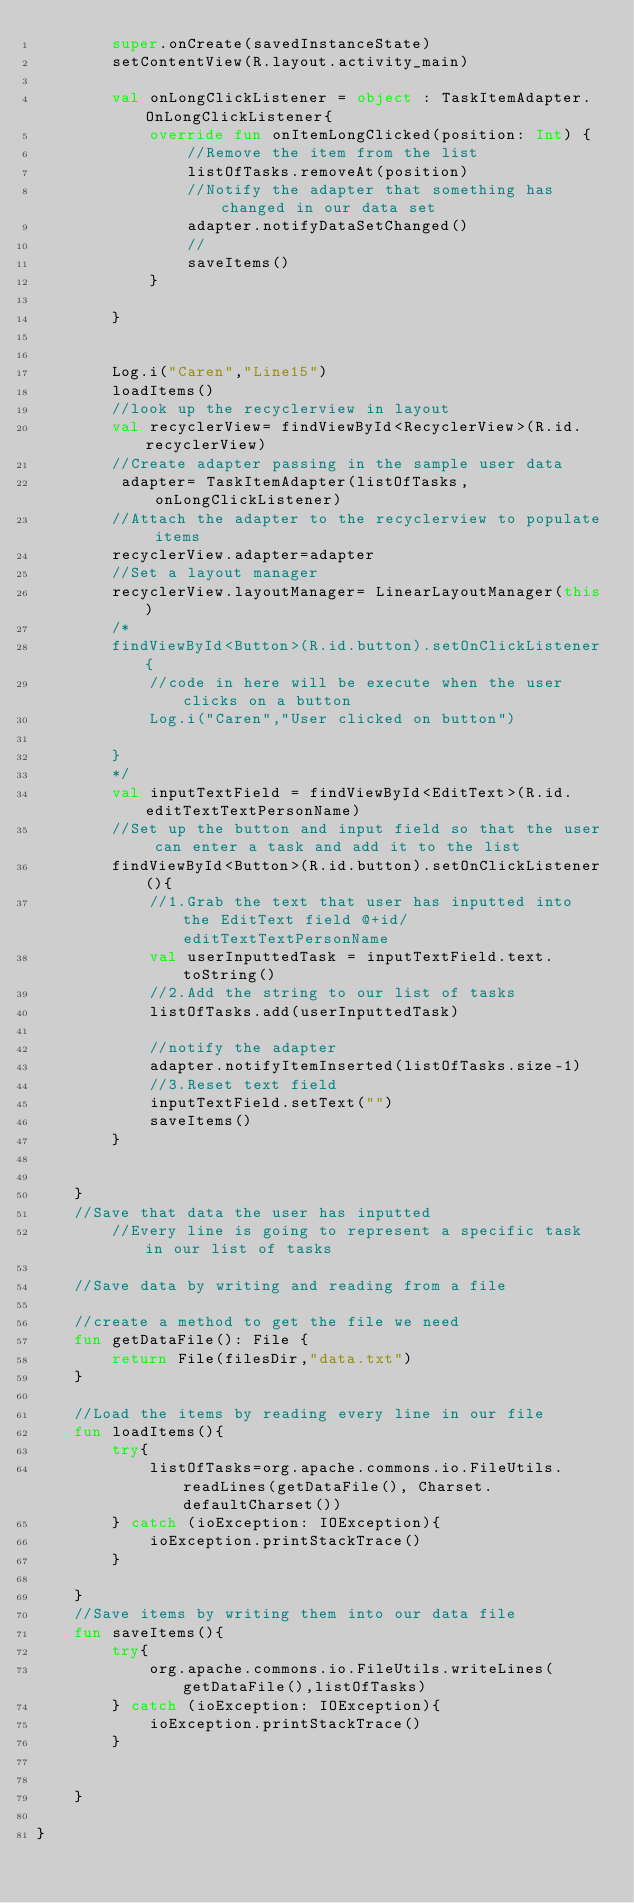Convert code to text. <code><loc_0><loc_0><loc_500><loc_500><_Kotlin_>        super.onCreate(savedInstanceState)
        setContentView(R.layout.activity_main)

        val onLongClickListener = object : TaskItemAdapter.OnLongClickListener{
            override fun onItemLongClicked(position: Int) {
                //Remove the item from the list
                listOfTasks.removeAt(position)
                //Notify the adapter that something has changed in our data set
                adapter.notifyDataSetChanged()
                //
                saveItems()
            }

        }


        Log.i("Caren","Line15")
        loadItems()
        //look up the recyclerview in layout
        val recyclerView= findViewById<RecyclerView>(R.id.recyclerView)
        //Create adapter passing in the sample user data
         adapter= TaskItemAdapter(listOfTasks,onLongClickListener)
        //Attach the adapter to the recyclerview to populate items
        recyclerView.adapter=adapter
        //Set a layout manager
        recyclerView.layoutManager= LinearLayoutManager(this)
        /*
        findViewById<Button>(R.id.button).setOnClickListener{
            //code in here will be execute when the user clicks on a button
            Log.i("Caren","User clicked on button")

        }
        */
        val inputTextField = findViewById<EditText>(R.id.editTextTextPersonName)
        //Set up the button and input field so that the user can enter a task and add it to the list
        findViewById<Button>(R.id.button).setOnClickListener(){
            //1.Grab the text that user has inputted into the EditText field @+id/editTextTextPersonName
            val userInputtedTask = inputTextField.text.toString()
            //2.Add the string to our list of tasks
            listOfTasks.add(userInputtedTask)

            //notify the adapter
            adapter.notifyItemInserted(listOfTasks.size-1)
            //3.Reset text field
            inputTextField.setText("")
            saveItems()
        }
        

    }
    //Save that data the user has inputted
        //Every line is going to represent a specific task in our list of tasks

    //Save data by writing and reading from a file

    //create a method to get the file we need
    fun getDataFile(): File {
        return File(filesDir,"data.txt")
    }

    //Load the items by reading every line in our file
    fun loadItems(){
        try{
            listOfTasks=org.apache.commons.io.FileUtils.readLines(getDataFile(), Charset.defaultCharset())
        } catch (ioException: IOException){
            ioException.printStackTrace()
        }

    }
    //Save items by writing them into our data file
    fun saveItems(){
        try{
            org.apache.commons.io.FileUtils.writeLines(getDataFile(),listOfTasks)
        } catch (ioException: IOException){
            ioException.printStackTrace()
        }


    }

}</code> 